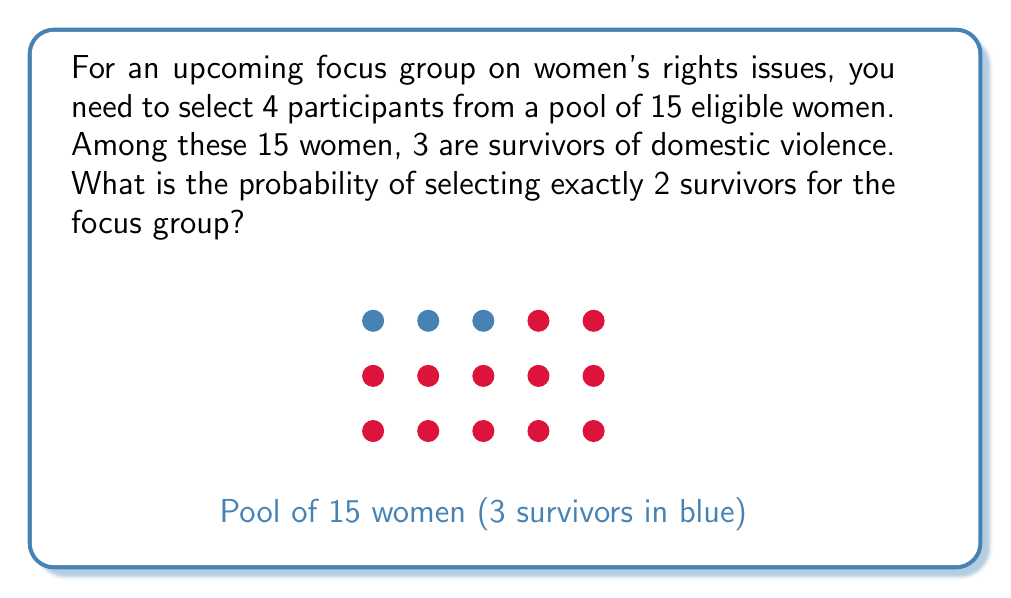Provide a solution to this math problem. Let's approach this step-by-step:

1) We need to use the hypergeometric distribution, as we're selecting without replacement from a finite population.

2) The probability is calculated as:

   $$P(X=k) = \frac{\binom{K}{k} \binom{N-K}{n-k}}{\binom{N}{n}}$$

   Where:
   $N$ = total population size (15 women)
   $K$ = number of success states in the population (3 survivors)
   $n$ = number of draws (4 participants)
   $k$ = number of observed successes (2 survivors)

3) Plugging in our values:

   $$P(X=2) = \frac{\binom{3}{2} \binom{15-3}{4-2}}{\binom{15}{4}}$$

4) Calculate each combination:
   
   $\binom{3}{2} = 3$
   $\binom{12}{2} = 66$
   $\binom{15}{4} = 1365$

5) Substituting:

   $$P(X=2) = \frac{3 \cdot 66}{1365} = \frac{198}{1365}$$

6) Simplify:

   $$P(X=2) = \frac{66}{455} \approx 0.1451$$
Answer: $\frac{66}{455}$ or approximately 0.1451 